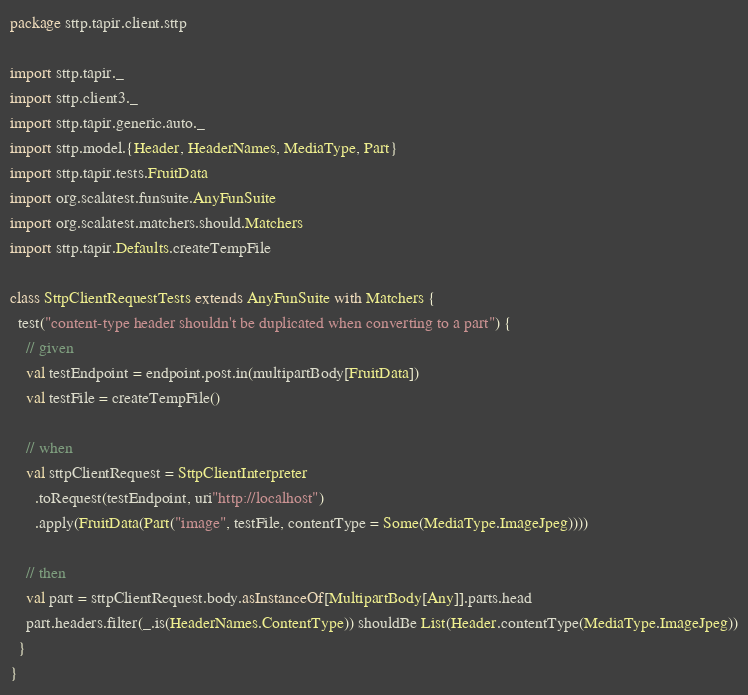<code> <loc_0><loc_0><loc_500><loc_500><_Scala_>package sttp.tapir.client.sttp

import sttp.tapir._
import sttp.client3._
import sttp.tapir.generic.auto._
import sttp.model.{Header, HeaderNames, MediaType, Part}
import sttp.tapir.tests.FruitData
import org.scalatest.funsuite.AnyFunSuite
import org.scalatest.matchers.should.Matchers
import sttp.tapir.Defaults.createTempFile

class SttpClientRequestTests extends AnyFunSuite with Matchers {
  test("content-type header shouldn't be duplicated when converting to a part") {
    // given
    val testEndpoint = endpoint.post.in(multipartBody[FruitData])
    val testFile = createTempFile()

    // when
    val sttpClientRequest = SttpClientInterpreter
      .toRequest(testEndpoint, uri"http://localhost")
      .apply(FruitData(Part("image", testFile, contentType = Some(MediaType.ImageJpeg))))

    // then
    val part = sttpClientRequest.body.asInstanceOf[MultipartBody[Any]].parts.head
    part.headers.filter(_.is(HeaderNames.ContentType)) shouldBe List(Header.contentType(MediaType.ImageJpeg))
  }
}
</code> 